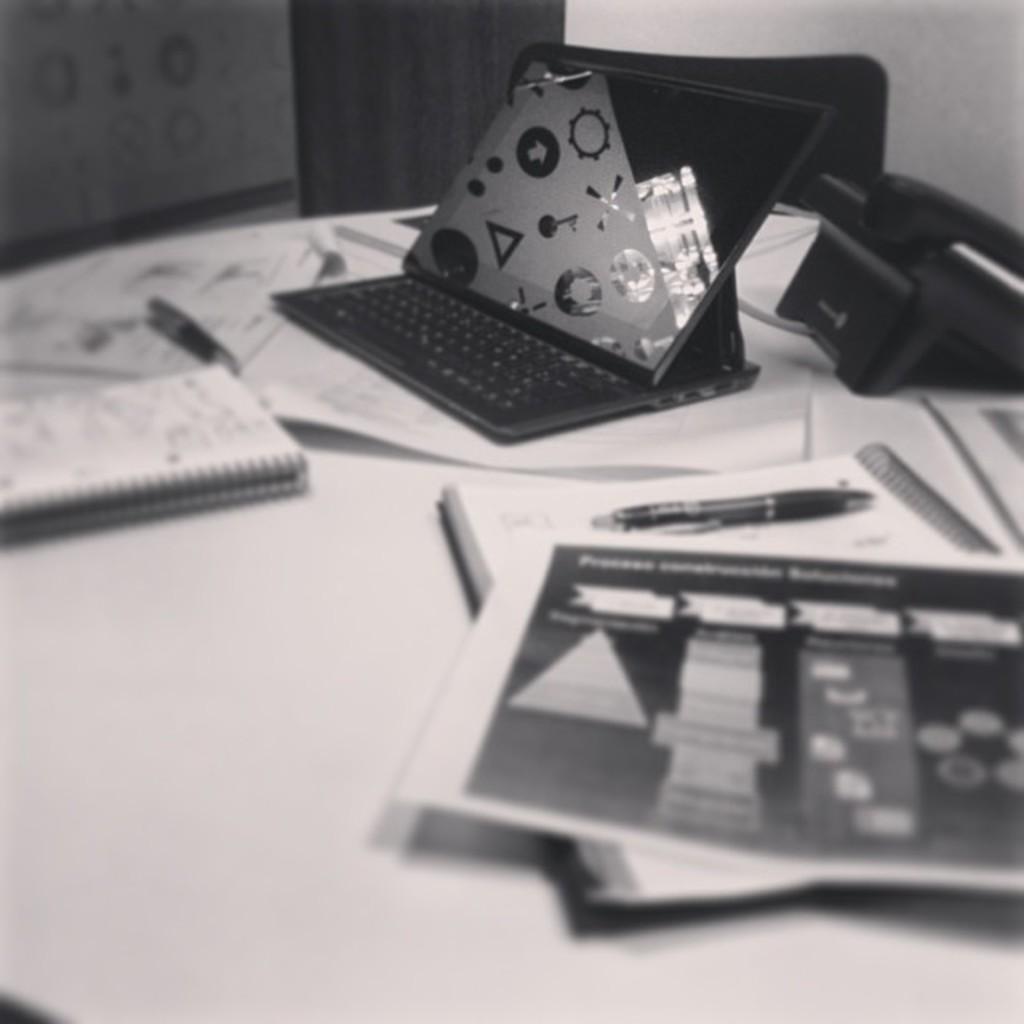In one or two sentences, can you explain what this image depicts? This is black and white image, in this image there is a table, on that table, there are books, pen, telephone, laptop, behind the table there are chairs. 